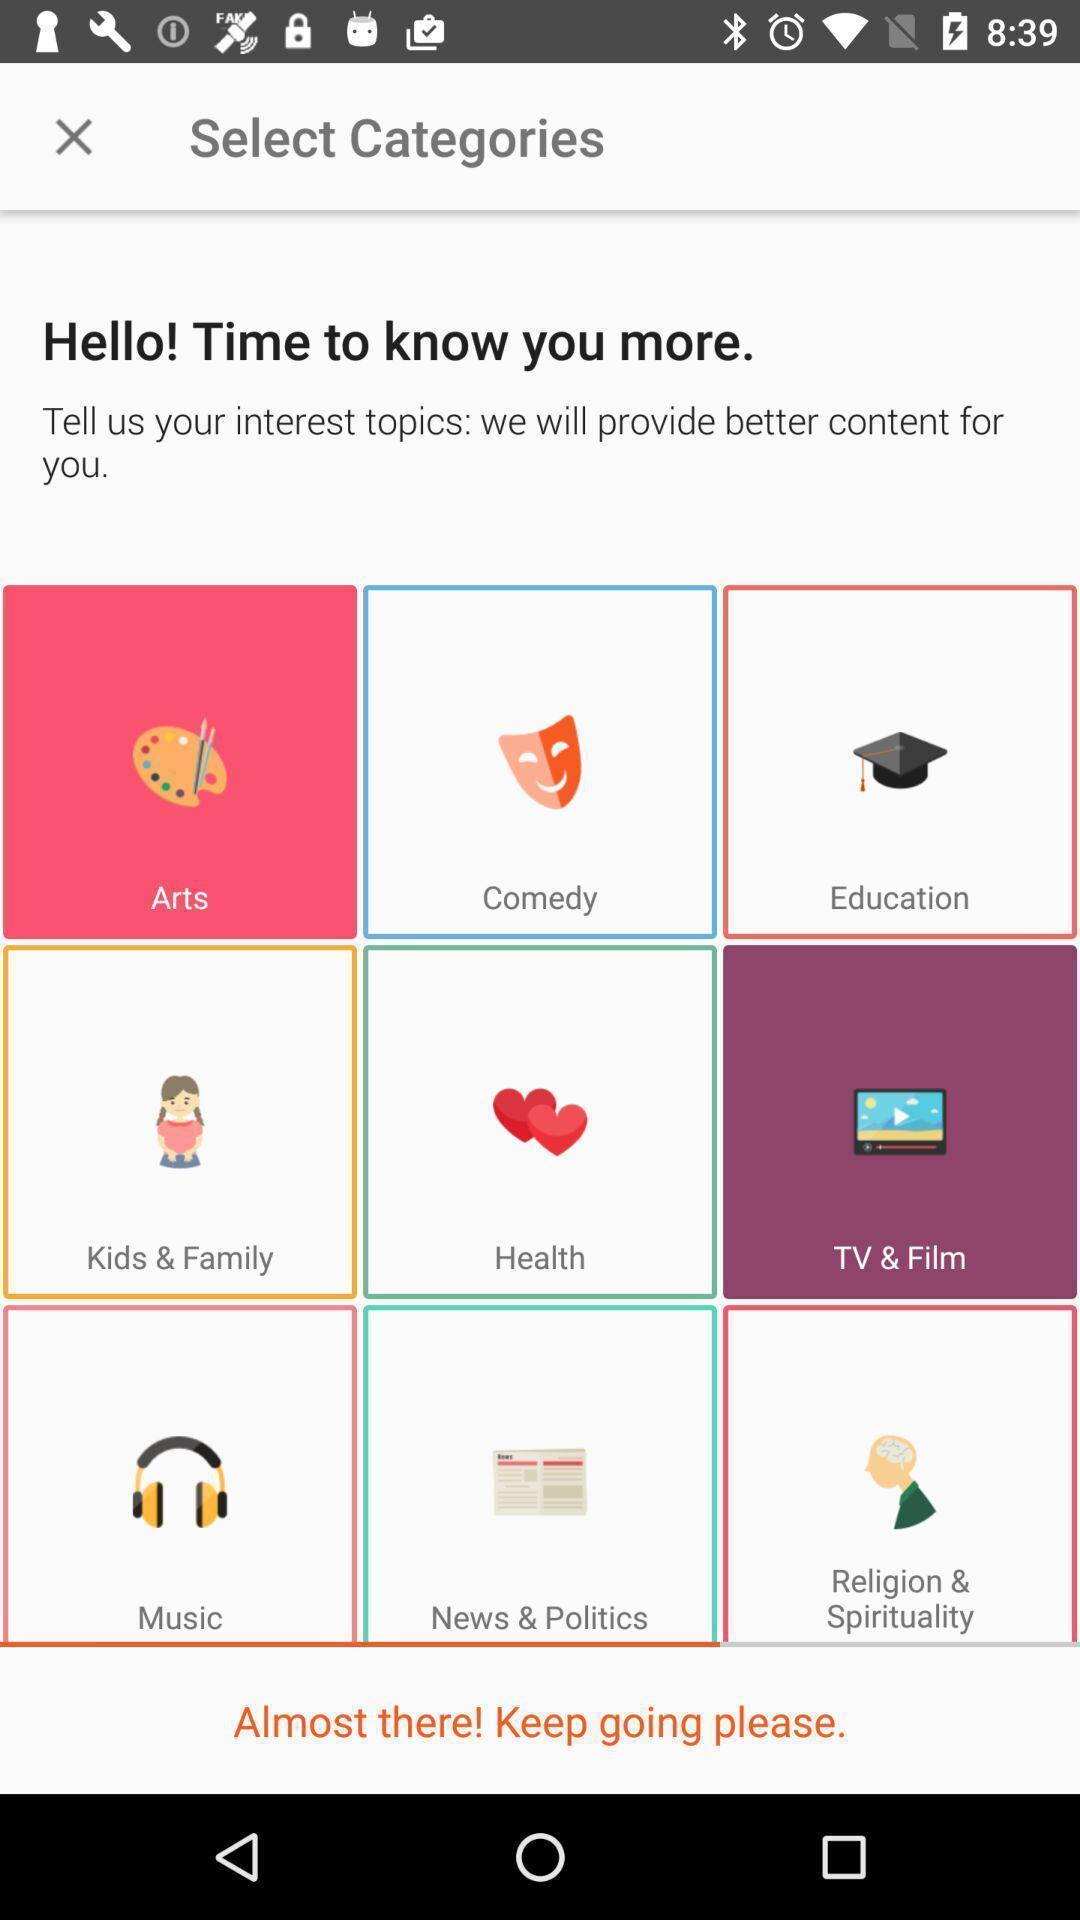What is the overall content of this screenshot? Window displaying top trending apps. 